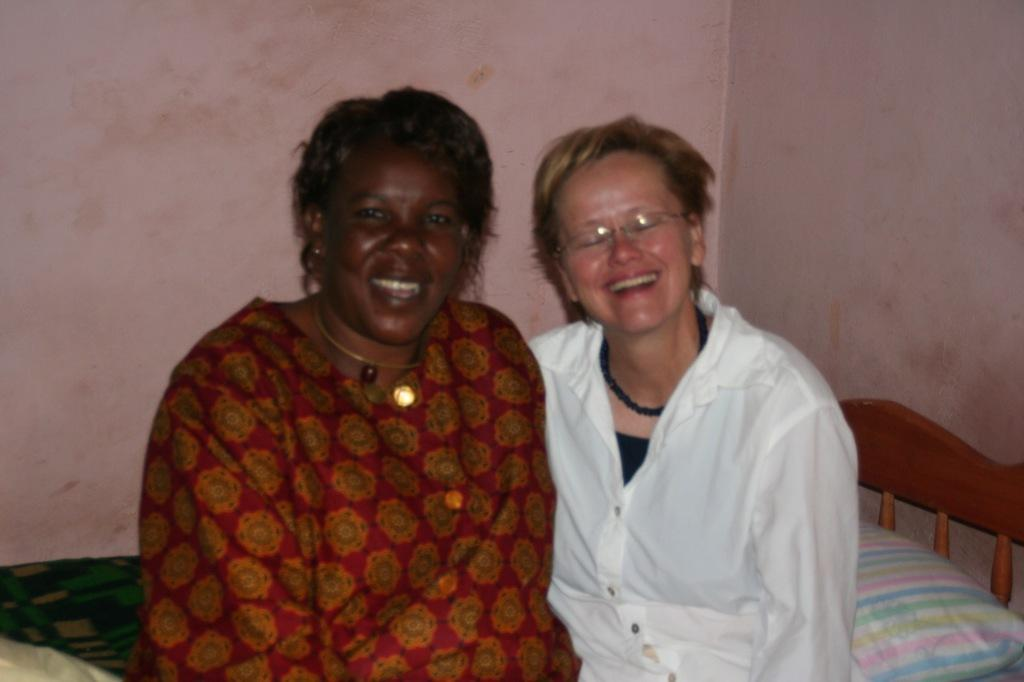How many women are in the image? There are 2 women in the image. What are the women doing in the image? The women are sitting in a bed and smiling. What can be seen in the background of the image? There are pillows, a blanket, and a wall in the background of the image. What is the income of the women in the image? There is no information about the income of the women in the image. Can you tell me where the nearest park is in relation to the women in the image? There is no information about a park or its location in the image. 